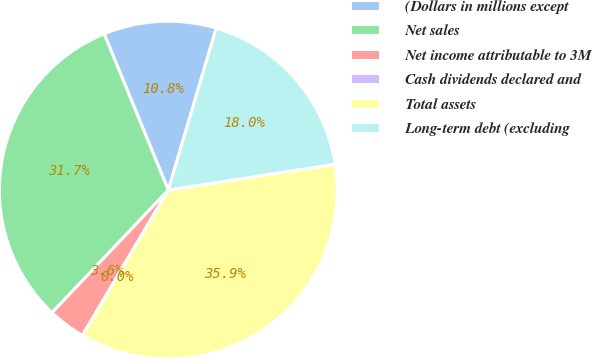<chart> <loc_0><loc_0><loc_500><loc_500><pie_chart><fcel>(Dollars in millions except<fcel>Net sales<fcel>Net income attributable to 3M<fcel>Cash dividends declared and<fcel>Total assets<fcel>Long-term debt (excluding<nl><fcel>10.78%<fcel>31.72%<fcel>3.6%<fcel>0.0%<fcel>35.93%<fcel>17.97%<nl></chart> 